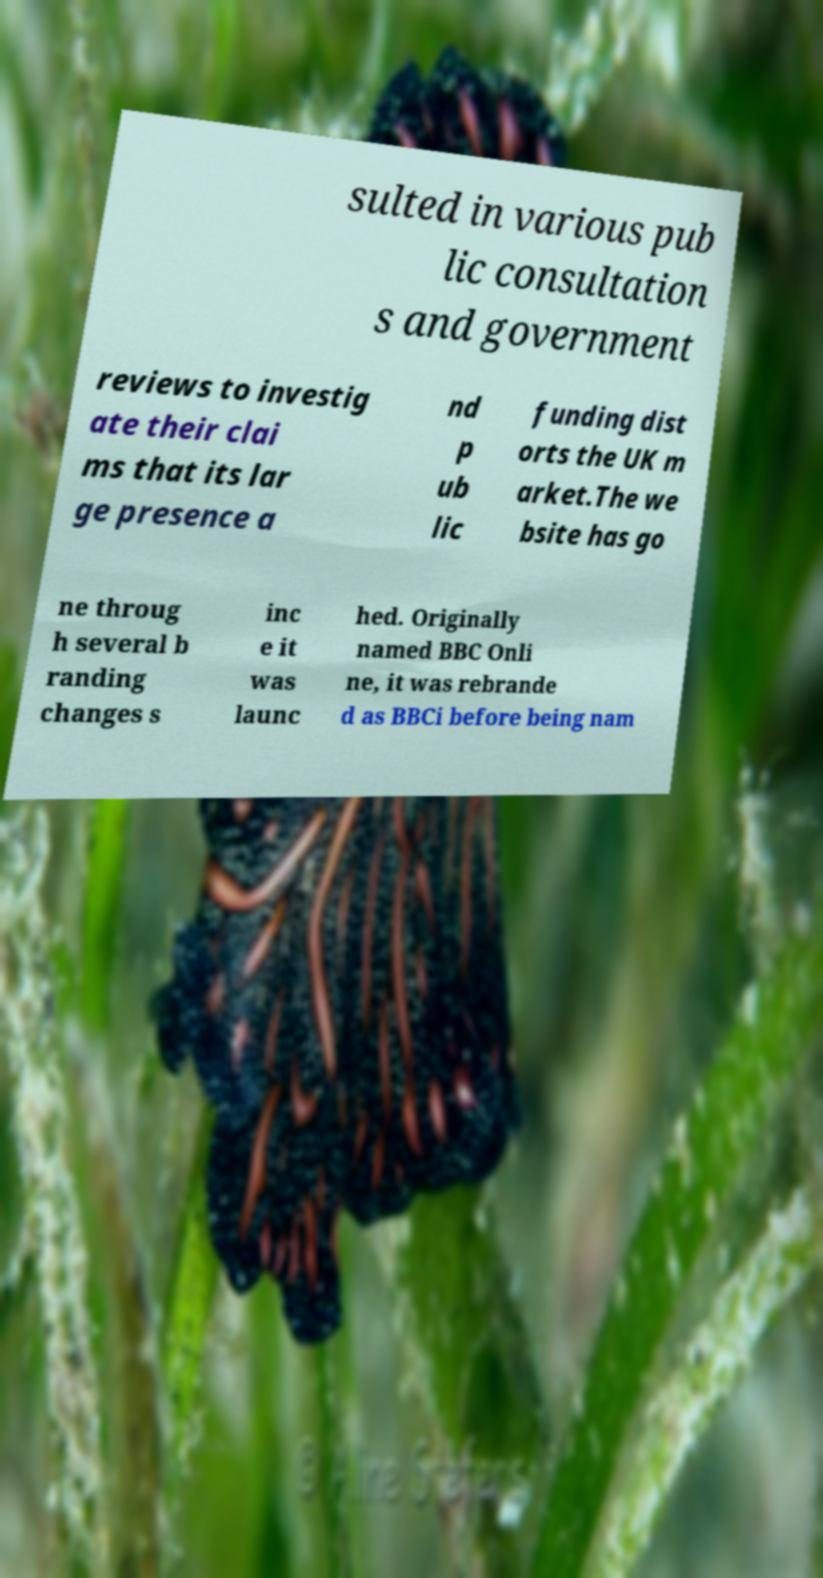There's text embedded in this image that I need extracted. Can you transcribe it verbatim? sulted in various pub lic consultation s and government reviews to investig ate their clai ms that its lar ge presence a nd p ub lic funding dist orts the UK m arket.The we bsite has go ne throug h several b randing changes s inc e it was launc hed. Originally named BBC Onli ne, it was rebrande d as BBCi before being nam 